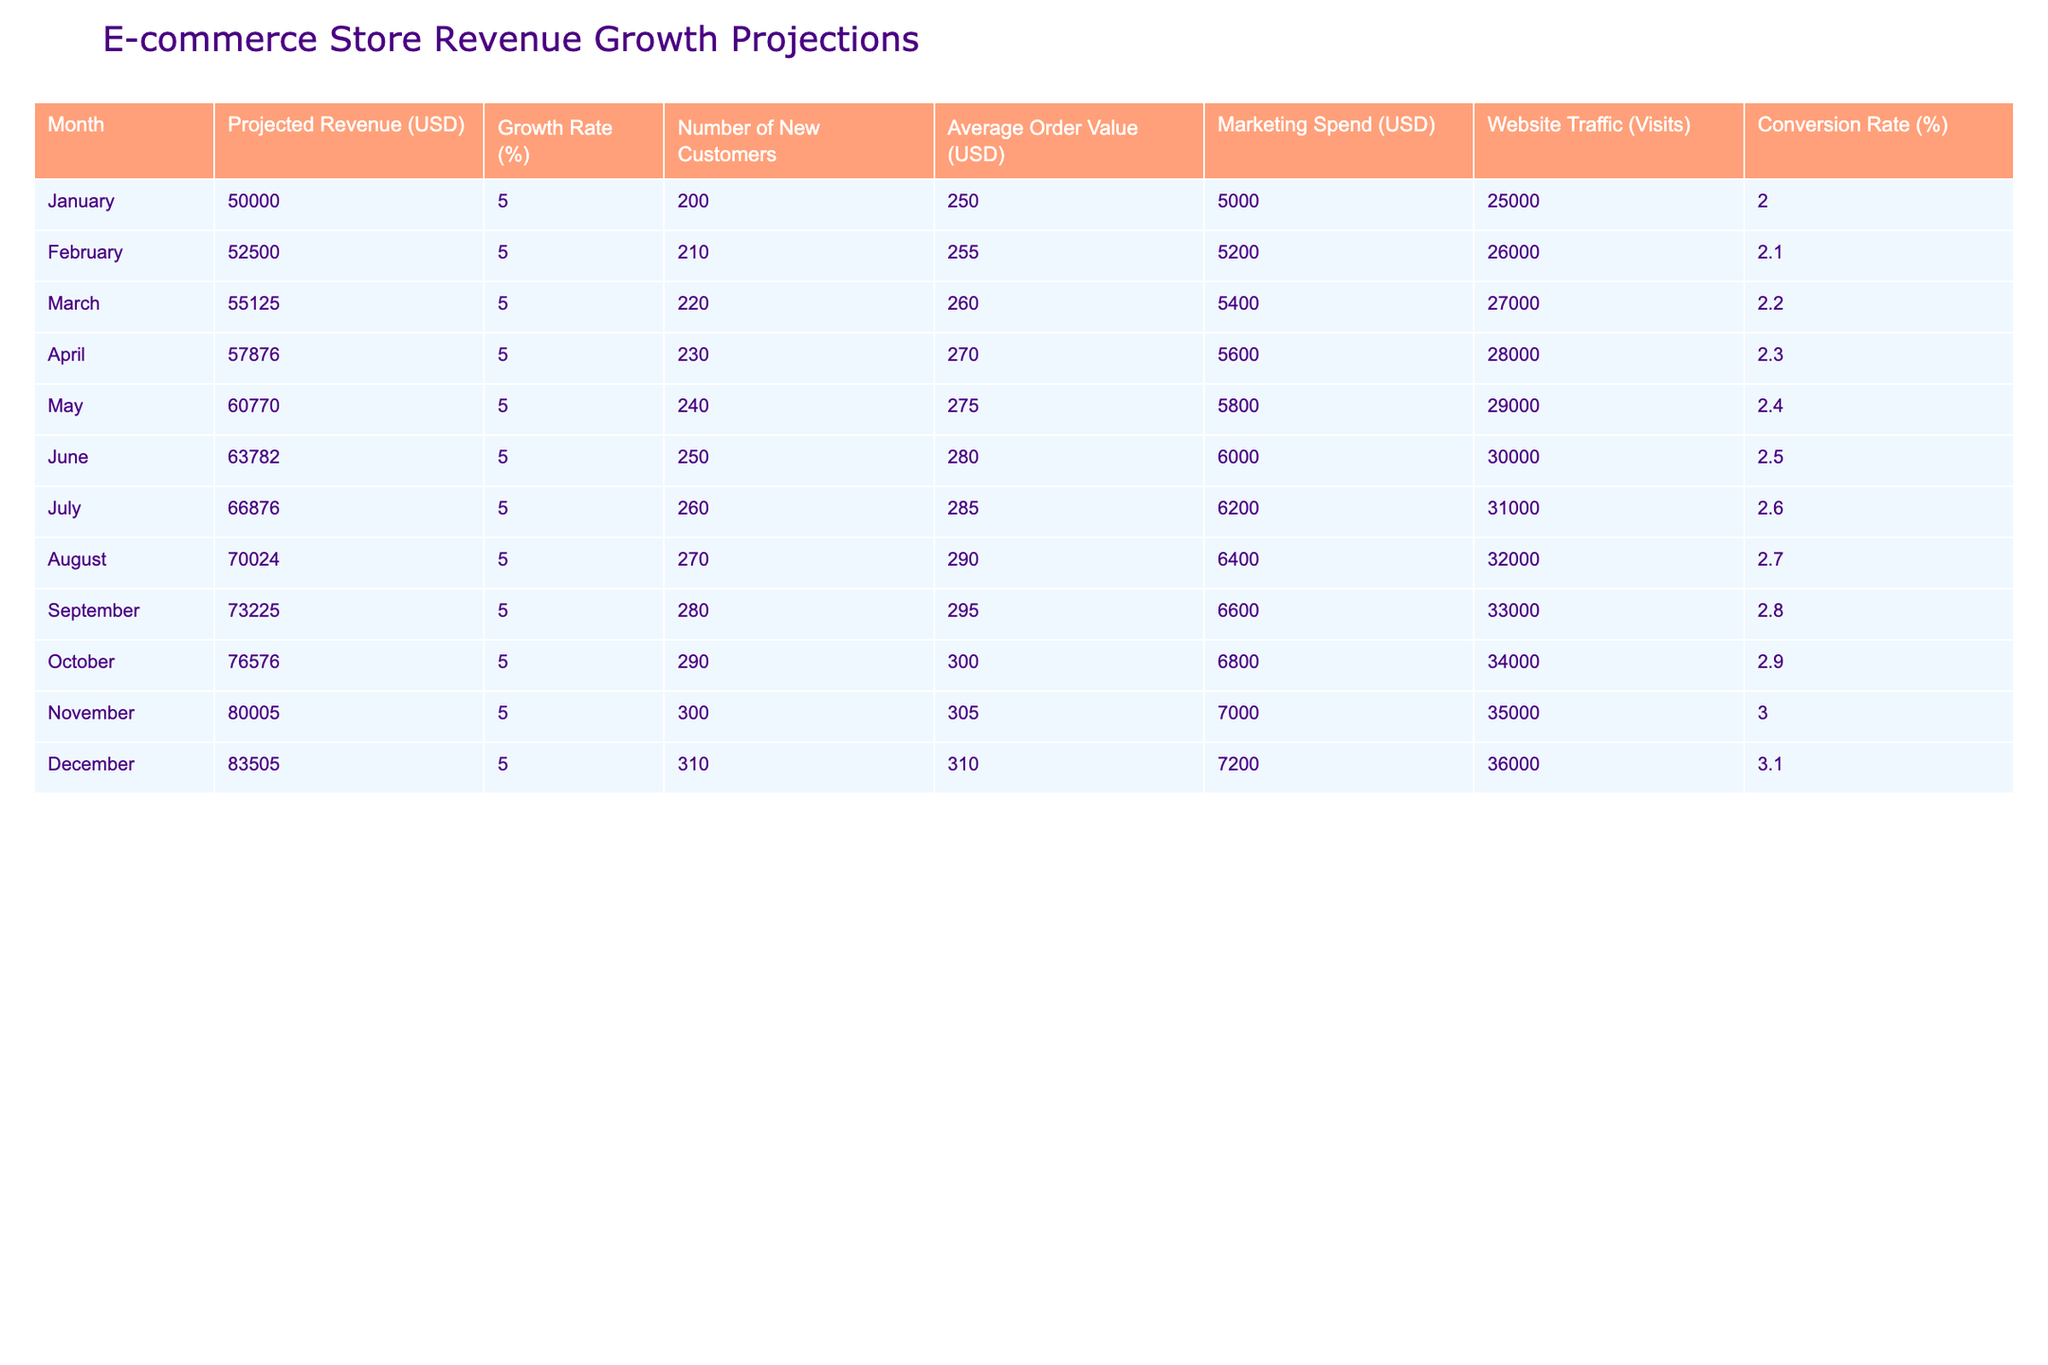What is the projected revenue for December? The projected revenue for December can be found directly from the table under the "Projected Revenue (USD)" column for December. The value listed is 83505.
Answer: 83505 What is the average marketing spend from January to March? To find the average marketing spend from January to March, first, sum the marketing spend values for those months: 5000 + 5200 + 5400 = 15600. Then, divide by the number of months (3) to get the average: 15600 / 3 = 5200.
Answer: 5200 Is the average order value for October higher than in September? The average order value for October is 300, and for September it is 295. Since 300 is greater than 295, the statement is true.
Answer: Yes How many new customers are projected for July? The number of new customers for July is directly provided in the table under the "Number of New Customers" column for July, which lists the value as 260.
Answer: 260 What is the total projected revenue growth from January to June? To calculate the total projected revenue growth from January to June, first, find the revenue for January (50000) and for June (63782). Then, subtract the January revenue from the June revenue: 63782 - 50000 = 13782. This is the total growth over that period.
Answer: 13782 What was the marketing spend for the month with the highest conversion rate? The highest conversion rate is found in December at 3.1%. The corresponding marketing spend for that month is 7200.
Answer: 7200 What is the projected revenue for the month with the highest number of new customers? The month with the highest number of new customers is December (310). The projected revenue for that month is located under "Projected Revenue (USD)" and is 83505.
Answer: 83505 How does the marketing spend from April to August compare to that from September to December? The total marketing spend from April to August is: 5600 + 5800 + 6000 + 6200 + 6400 = 30000. The total from September to December is: 6600 + 6800 + 7000 + 7200 = 28600. Since 30000 is greater than 28600, we see that marketing spend was higher from April to August.
Answer: Higher from April to August Is the conversion rate consistently increasing each month? The conversion rates are 2, 2.1, 2.2, 2.3, 2.4, 2.5, 2.6, 2.7, 2.8, 2.9, 3, and 3.1, which shows a clear upward trend, confirming that the conversion rates are consistently increasing each month.
Answer: Yes 